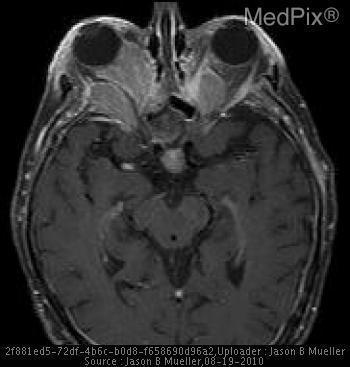Is the finding normal?
Concise answer only. No. Where is the enhancement in left rectus muscles?
Write a very short answer. Medial rectus. Which rectus muscles are enhanced on the left?
Answer briefly. Medial rectus. Where is the enhancement in right rectus muscles?
Quick response, please. Medial and lateral rectus. Which rectus muscles are enhanced on the right?
Write a very short answer. Medial and lateral rectus. Are the enhanced muscles also enlarged?
Give a very brief answer. Yes. Do the enhanced muscles appear enlarged?
Be succinct. Yes. 